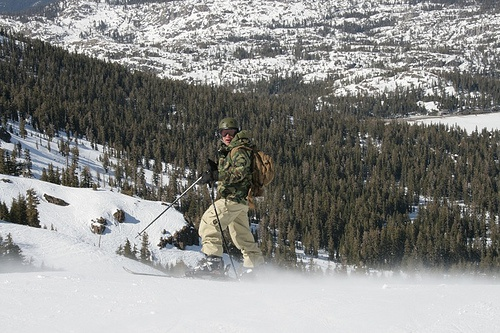Describe the objects in this image and their specific colors. I can see people in gray, black, and darkgray tones, skis in gray, darkgray, and lightgray tones, and backpack in gray and black tones in this image. 